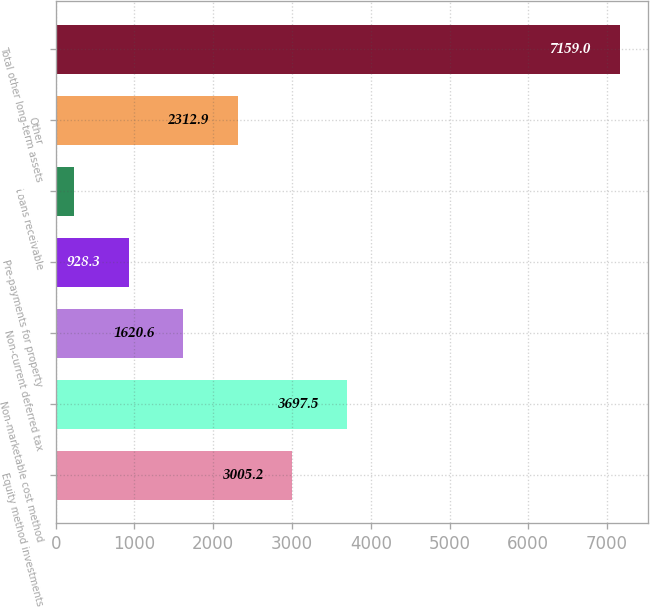Convert chart to OTSL. <chart><loc_0><loc_0><loc_500><loc_500><bar_chart><fcel>Equity method investments<fcel>Non-marketable cost method<fcel>Non-current deferred tax<fcel>Pre-payments for property<fcel>Loans receivable<fcel>Other<fcel>Total other long-term assets<nl><fcel>3005.2<fcel>3697.5<fcel>1620.6<fcel>928.3<fcel>236<fcel>2312.9<fcel>7159<nl></chart> 